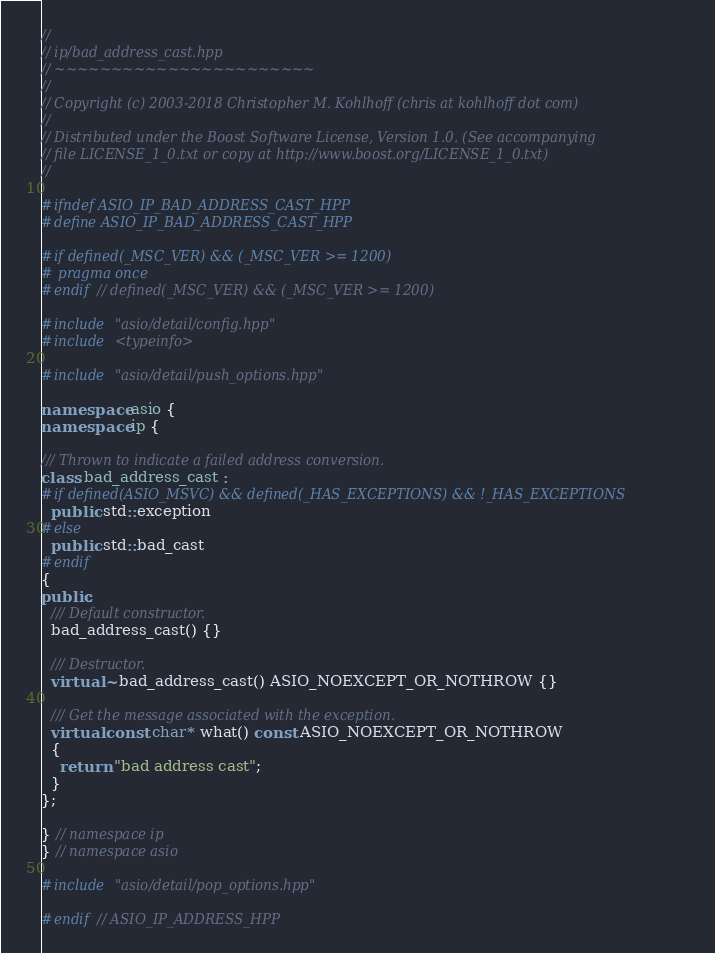<code> <loc_0><loc_0><loc_500><loc_500><_C++_>//
// ip/bad_address_cast.hpp
// ~~~~~~~~~~~~~~~~~~~~~~~
//
// Copyright (c) 2003-2018 Christopher M. Kohlhoff (chris at kohlhoff dot com)
//
// Distributed under the Boost Software License, Version 1.0. (See accompanying
// file LICENSE_1_0.txt or copy at http://www.boost.org/LICENSE_1_0.txt)
//

#ifndef ASIO_IP_BAD_ADDRESS_CAST_HPP
#define ASIO_IP_BAD_ADDRESS_CAST_HPP

#if defined(_MSC_VER) && (_MSC_VER >= 1200)
# pragma once
#endif // defined(_MSC_VER) && (_MSC_VER >= 1200)

#include "asio/detail/config.hpp"
#include <typeinfo>

#include "asio/detail/push_options.hpp"

namespace asio {
namespace ip {

/// Thrown to indicate a failed address conversion.
class bad_address_cast :
#if defined(ASIO_MSVC) && defined(_HAS_EXCEPTIONS) && !_HAS_EXCEPTIONS
  public std::exception
#else
  public std::bad_cast
#endif
{
public:
  /// Default constructor.
  bad_address_cast() {}

  /// Destructor.
  virtual ~bad_address_cast() ASIO_NOEXCEPT_OR_NOTHROW {}

  /// Get the message associated with the exception.
  virtual const char* what() const ASIO_NOEXCEPT_OR_NOTHROW
  {
    return "bad address cast";
  }
};

} // namespace ip
} // namespace asio

#include "asio/detail/pop_options.hpp"

#endif // ASIO_IP_ADDRESS_HPP
</code> 